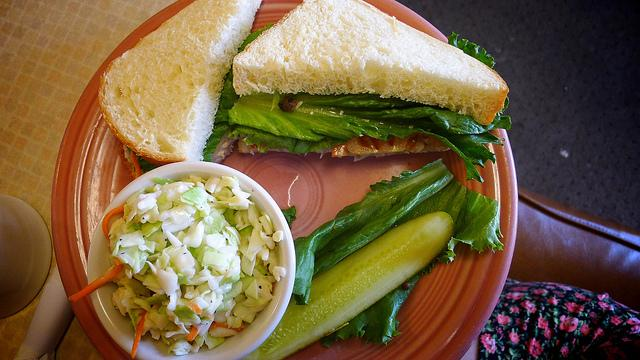From which vegetable is the main side dish sourced from mainly? cabbage 